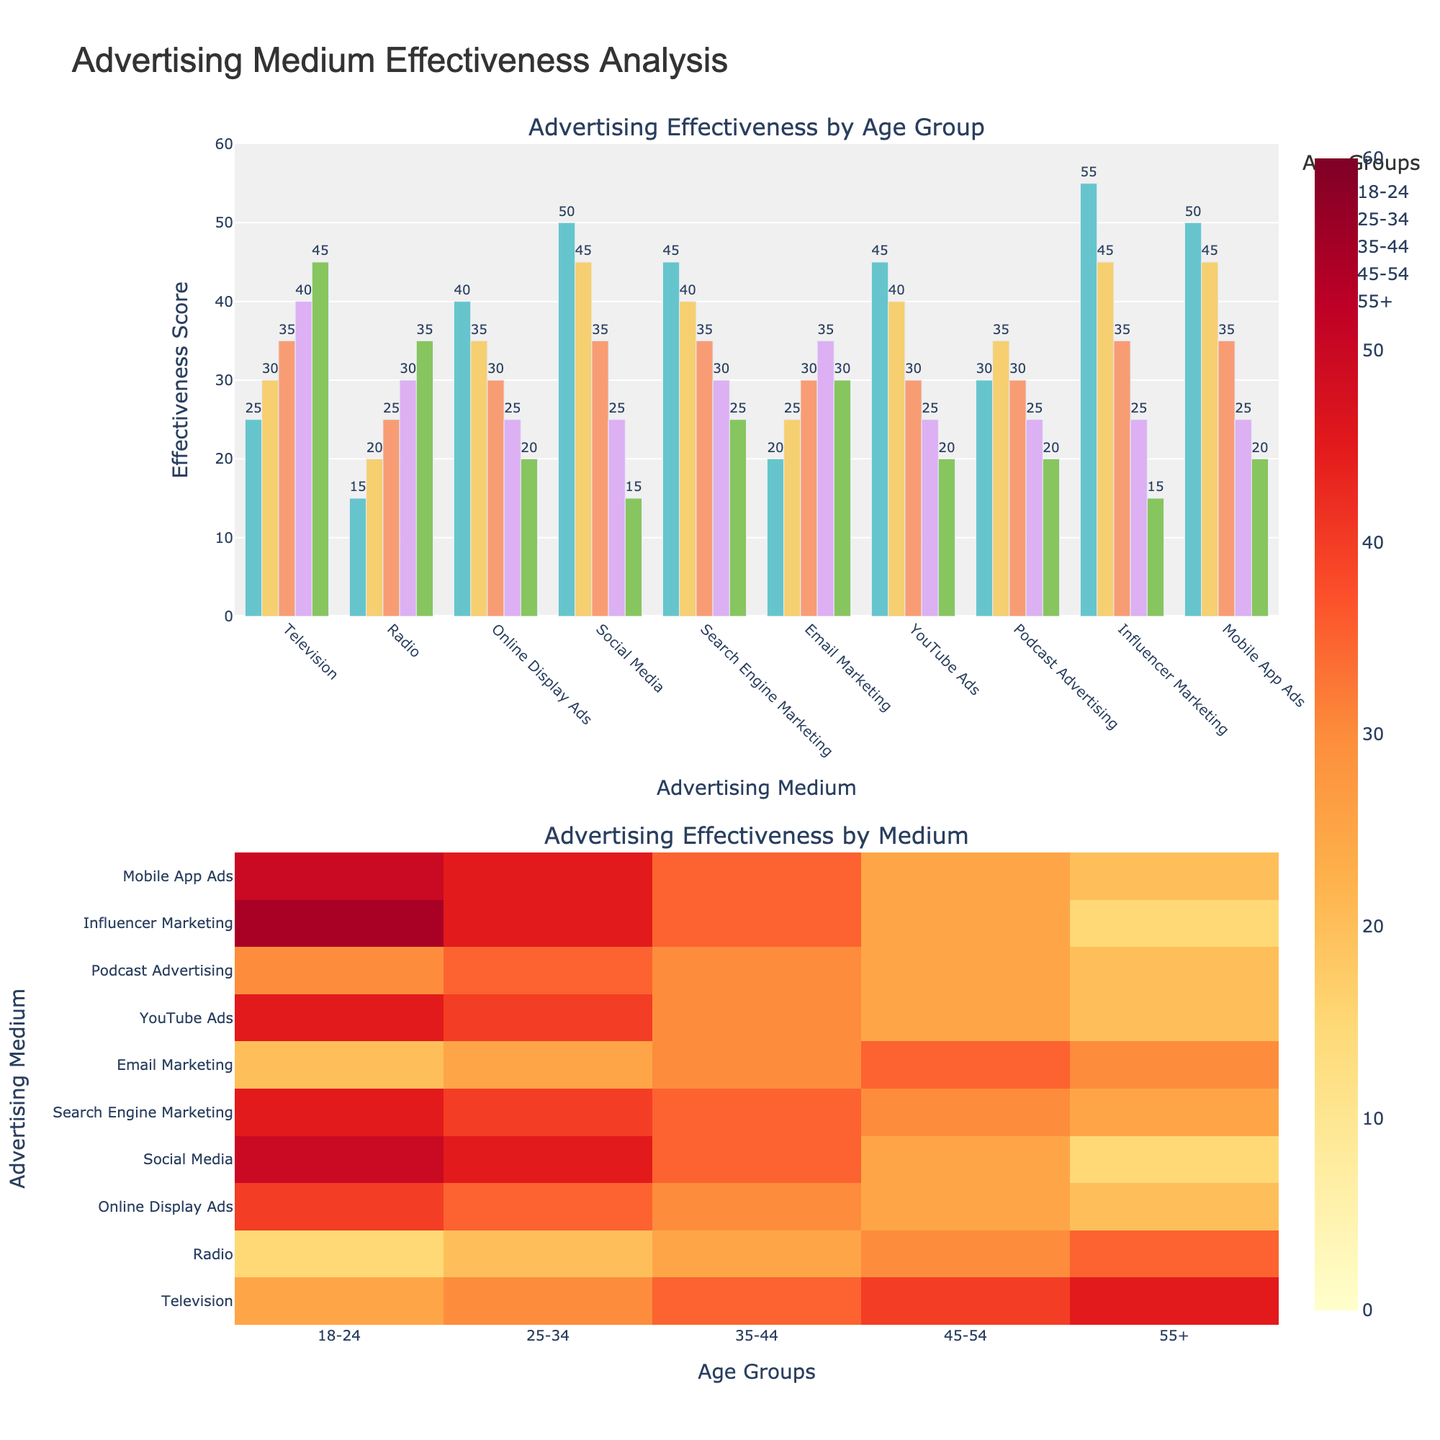Which medium is most effective for the 18-24 age group? The bar chart shows that "Influencer Marketing" and "Mobile App Ads" have the highest bars for the 18-24 age group, both reaching an effectiveness score of 55 and 50 respectively.
Answer: Influencer Marketing How does the effectiveness of Social Media compare across different age groups? By observing the Social Media bars, we see it is most effective for the 18-24 age group (50), decreases for the 25-34 group (45), further decreases for the 35-44 group (35), drops for the 45-54 group (25), and is least effective for the 55+ group (15).
Answer: Decreasing from 18-24 to 55+ What is the total effectiveness score of Television for all age groups combined? To find the total, sum the effectiveness scores for Television across all age groups: 25 (18-24) + 30 (25-34) + 35 (35-44) + 40 (45-54) + 45 (55+) = 175.
Answer: 175 Which age group finds Email Marketing most effective? The heatmap section visually shows the highest intensity (color) for the 45-54 age group, indicating the highest effectiveness score for Email Marketing.
Answer: 45-54 Between Podcast Advertising and YouTube Ads, which has higher effectiveness for the 35-44 age group? Comparing the heights of the bars for the 35-44 age group, Podcast Advertising has a score of 30, while YouTube Ads have a score of 30, making them equal.
Answer: Equal What is the combined effectiveness score for Online Display Ads and Search Engine Marketing for the 25-34 age group? Sum the effectiveness scores of both Online Display Ads (35) and Search Engine Marketing (40) for the 25-34 age group: 35 + 40 = 75.
Answer: 75 How does the effectiveness of Radio change from the youngest (18-24) to the oldest (55+) age group? Observing the bars for Radio, there is a steady increase from the youngest age group (15) up to the oldest age group (35).
Answer: Increasing What pattern can be observed in the effectiveness of Mobile App Ads across different age groups? The bars and heatmap show the highest effectiveness in the 18-24 age group (50) and 25-34 age group (45), declining in effectiveness in subsequent age groups (35: 35, 45-54: 25, 55+: 20).
Answer: Decreasing with age Which medium is least effective for the 45-54 age group? From the bar chart, "Social Media" and "Online Display Ads" have the lowest bars for the 45-54 age group, both at an effectiveness score of 25.
Answer: Online Display Ads, Social Media 